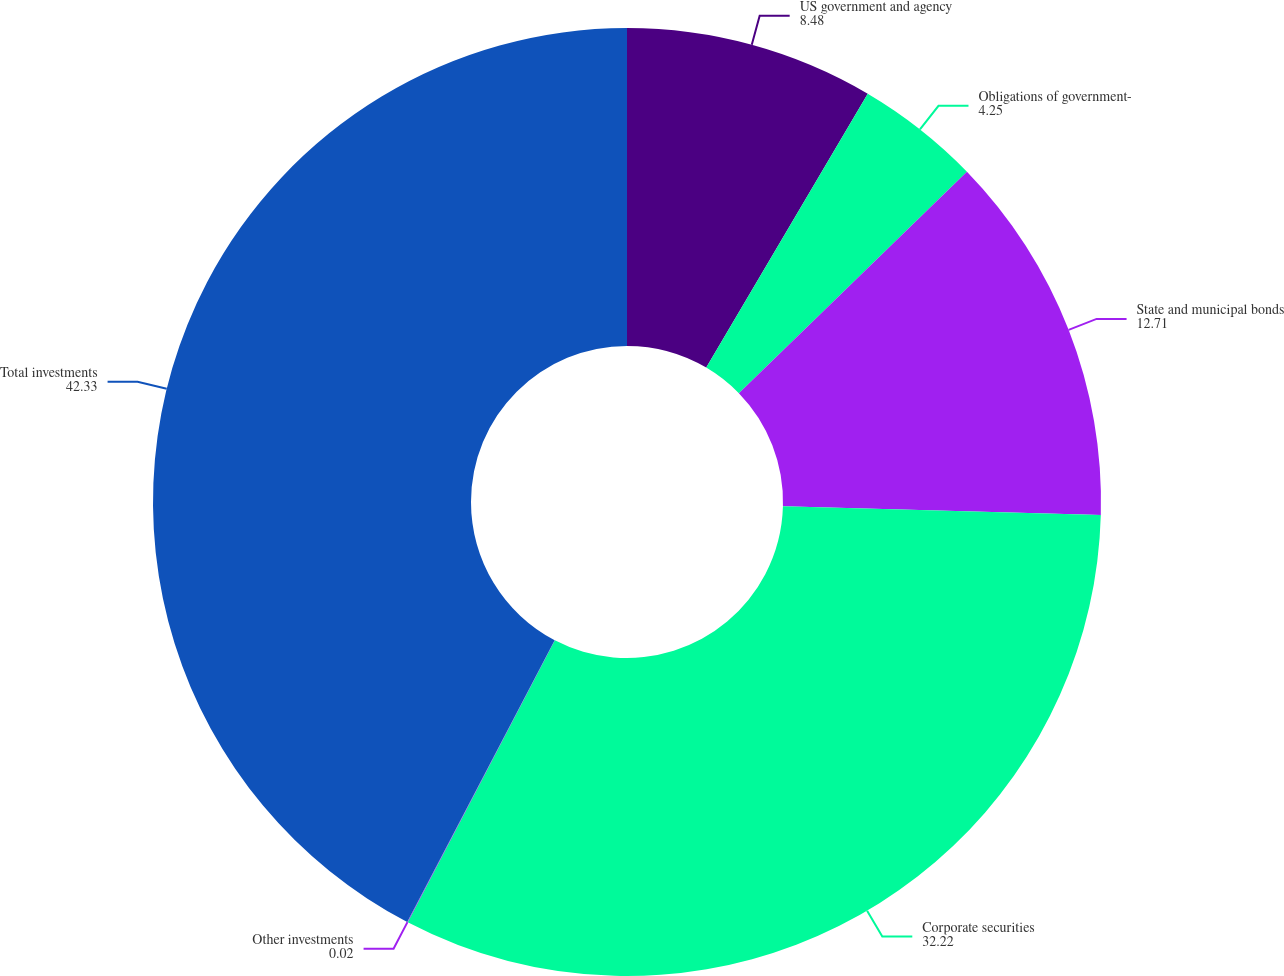<chart> <loc_0><loc_0><loc_500><loc_500><pie_chart><fcel>US government and agency<fcel>Obligations of government-<fcel>State and municipal bonds<fcel>Corporate securities<fcel>Other investments<fcel>Total investments<nl><fcel>8.48%<fcel>4.25%<fcel>12.71%<fcel>32.22%<fcel>0.02%<fcel>42.33%<nl></chart> 